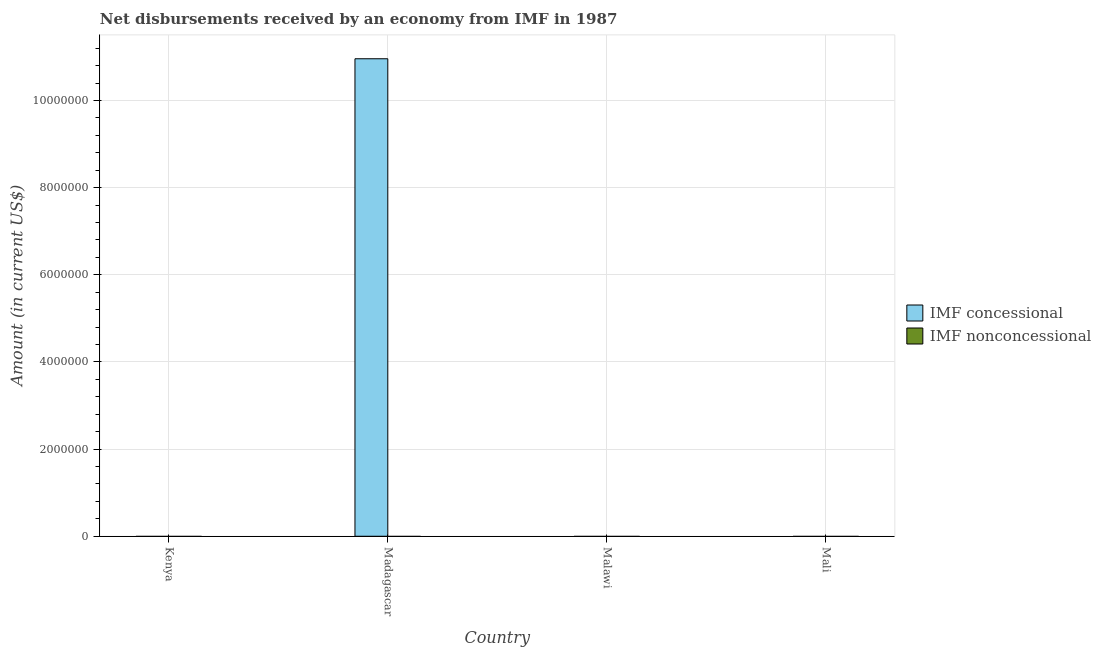How many different coloured bars are there?
Make the answer very short. 1. Are the number of bars per tick equal to the number of legend labels?
Make the answer very short. No. How many bars are there on the 3rd tick from the left?
Your answer should be compact. 0. What is the label of the 1st group of bars from the left?
Ensure brevity in your answer.  Kenya. In how many cases, is the number of bars for a given country not equal to the number of legend labels?
Provide a short and direct response. 4. What is the net concessional disbursements from imf in Malawi?
Offer a terse response. 0. Across all countries, what is the maximum net concessional disbursements from imf?
Provide a short and direct response. 1.10e+07. Across all countries, what is the minimum net concessional disbursements from imf?
Offer a terse response. 0. In which country was the net concessional disbursements from imf maximum?
Offer a very short reply. Madagascar. What is the difference between the net non concessional disbursements from imf in Madagascar and the net concessional disbursements from imf in Mali?
Your response must be concise. 0. What is the difference between the highest and the lowest net concessional disbursements from imf?
Offer a terse response. 1.10e+07. How many bars are there?
Your response must be concise. 1. Are all the bars in the graph horizontal?
Offer a very short reply. No. Does the graph contain grids?
Your answer should be very brief. Yes. Where does the legend appear in the graph?
Ensure brevity in your answer.  Center right. How many legend labels are there?
Your answer should be very brief. 2. How are the legend labels stacked?
Offer a very short reply. Vertical. What is the title of the graph?
Keep it short and to the point. Net disbursements received by an economy from IMF in 1987. What is the label or title of the X-axis?
Provide a short and direct response. Country. What is the Amount (in current US$) in IMF concessional in Kenya?
Your response must be concise. 0. What is the Amount (in current US$) of IMF nonconcessional in Kenya?
Your answer should be compact. 0. What is the Amount (in current US$) in IMF concessional in Madagascar?
Your answer should be very brief. 1.10e+07. What is the Amount (in current US$) in IMF concessional in Malawi?
Give a very brief answer. 0. What is the Amount (in current US$) in IMF nonconcessional in Malawi?
Provide a succinct answer. 0. What is the Amount (in current US$) in IMF concessional in Mali?
Make the answer very short. 0. Across all countries, what is the maximum Amount (in current US$) in IMF concessional?
Make the answer very short. 1.10e+07. Across all countries, what is the minimum Amount (in current US$) of IMF concessional?
Provide a succinct answer. 0. What is the total Amount (in current US$) in IMF concessional in the graph?
Your answer should be very brief. 1.10e+07. What is the total Amount (in current US$) of IMF nonconcessional in the graph?
Offer a terse response. 0. What is the average Amount (in current US$) in IMF concessional per country?
Provide a succinct answer. 2.74e+06. What is the difference between the highest and the lowest Amount (in current US$) in IMF concessional?
Your response must be concise. 1.10e+07. 